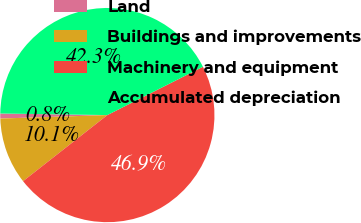Convert chart to OTSL. <chart><loc_0><loc_0><loc_500><loc_500><pie_chart><fcel>Land<fcel>Buildings and improvements<fcel>Machinery and equipment<fcel>Accumulated depreciation<nl><fcel>0.75%<fcel>10.07%<fcel>46.86%<fcel>42.32%<nl></chart> 